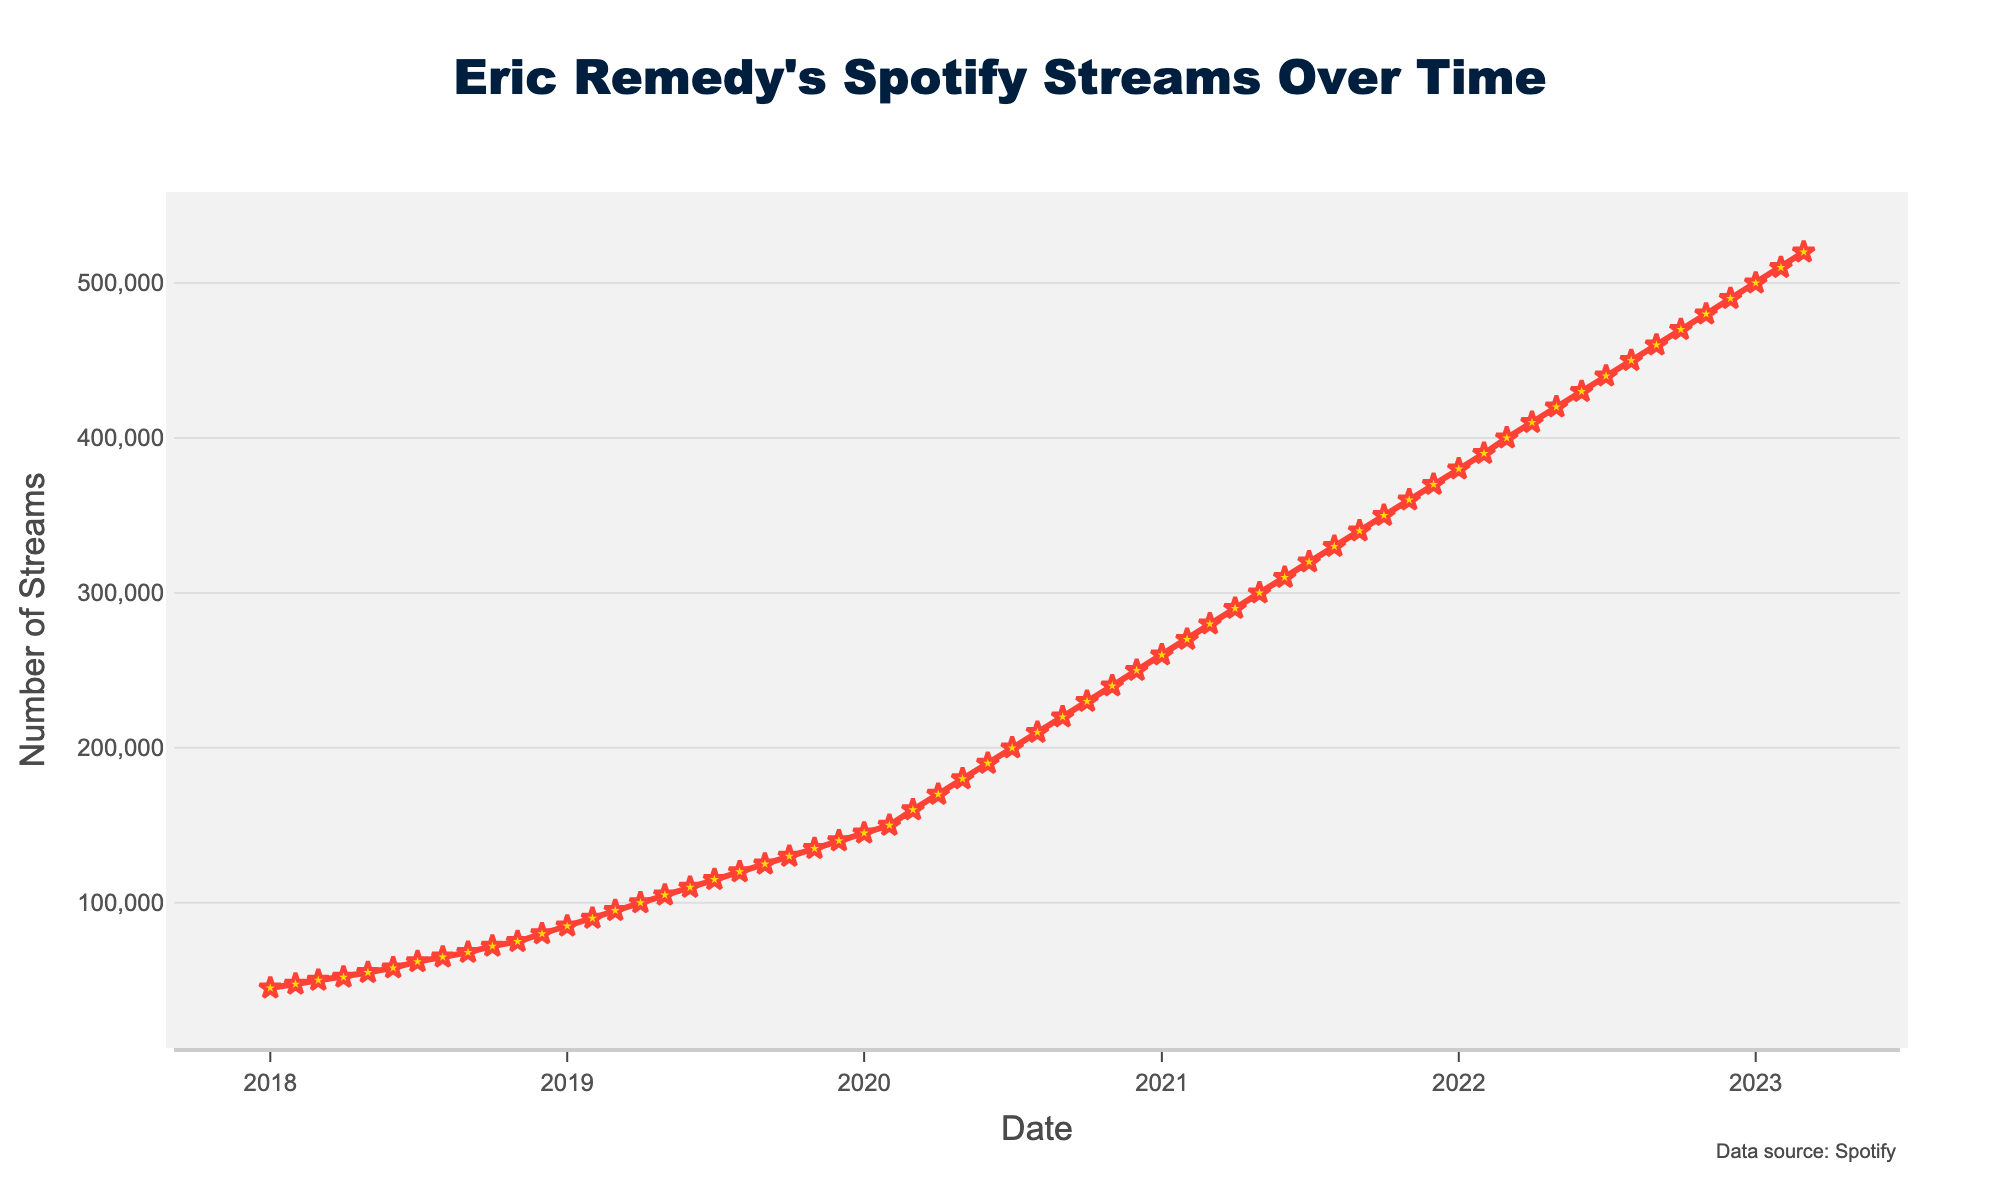When did Eric Remedy's monthly streams reach 100,000? The figure shows the trend of Eric Remedy's monthly streams over time. Look for the month where the streams first hit 100,000. It occurred in April 2019.
Answer: April 2019 By how much did Eric Remedy's streams increase from January 2019 to December 2019? Identify the streams in January 2019 (85,000) and December 2019 (140,000). Then, calculate the difference: 140,000 - 85,000 = 55,000.
Answer: 55,000 What is the highest number of monthly streams recorded in the figure? The highest point on the line chart represents the peak number of streams. In March 2023, the streams reach 520,000.
Answer: 520,000 Did Eric Remedy's streams ever decrease from one month to the next? Observe the slope of the line. It is consistently upward, indicating streams never decreased month-to-month in the given period.
Answer: No What is the average monthly increase in streams from January 2020 to December 2020? Calculate the monthly increase between January (145,000) and December (250,000). Subtract: 250,000 - 145,000 = 105,000, then divide by 11 (number of intervals): 105,000 / 11 ≈ 9,545.
Answer: 9,545 Between which two consecutive months was the largest increase in streams observed? Analyze the differences between each month's streams. The largest increase happens between March 2020 (160,000) and April 2020 (170,000): 170,000 - 160,000 = 10,000.
Answer: March 2020 and April 2020 How many months did it take for Eric Remedy's streams to double from 50,000? Identify the starting point, March 2018 (50,000), and find when it doubled to 100,000. This happened in April 2019. Count the months: March 2018 to April 2019 is 13 months.
Answer: 13 months What is the overall trend of Eric Remedy's Spotify streams over the past 5 years? The line chart shows a consistently upward trend with no dips, implying a steady increase in Spotify streams over the 5 years.
Answer: Upward trend How many times did Eric Remedy's streams surpass 200,000? Look at the points on the line chart where the streams exceed 200,000, starting in July 2020 and onwards. There are 32 such instances.
Answer: 32 